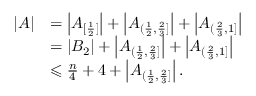<formula> <loc_0><loc_0><loc_500><loc_500>\begin{array} { r l } { | A | } & { = \left | A _ { [ \frac { 1 } { 2 } ] } \right | + \left | A _ { ( \frac { 1 } { 2 } , \frac { 2 } { 3 } ] } \right | + \left | A _ { ( \frac { 2 } { 3 } , 1 ] } \right | } \\ & { = | B _ { 2 } | + \left | A _ { ( \frac { 1 } { 2 } , \frac { 2 } { 3 } ] } \right | + \left | A _ { ( \frac { 2 } { 3 } , 1 ] } \right | } \\ & { \leqslant \frac { n } { 4 } + 4 + \left | A _ { ( \frac { 1 } { 2 } , \frac { 2 } { 3 } ] } \right | . } \end{array}</formula> 